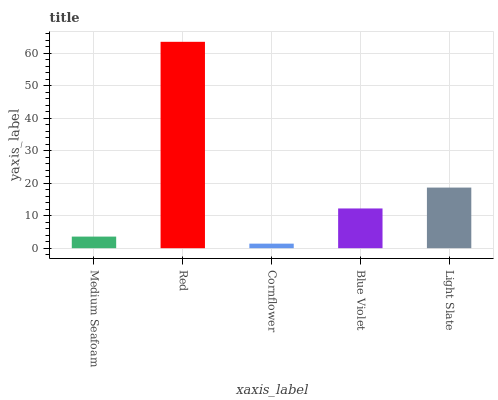Is Red the minimum?
Answer yes or no. No. Is Cornflower the maximum?
Answer yes or no. No. Is Red greater than Cornflower?
Answer yes or no. Yes. Is Cornflower less than Red?
Answer yes or no. Yes. Is Cornflower greater than Red?
Answer yes or no. No. Is Red less than Cornflower?
Answer yes or no. No. Is Blue Violet the high median?
Answer yes or no. Yes. Is Blue Violet the low median?
Answer yes or no. Yes. Is Cornflower the high median?
Answer yes or no. No. Is Medium Seafoam the low median?
Answer yes or no. No. 